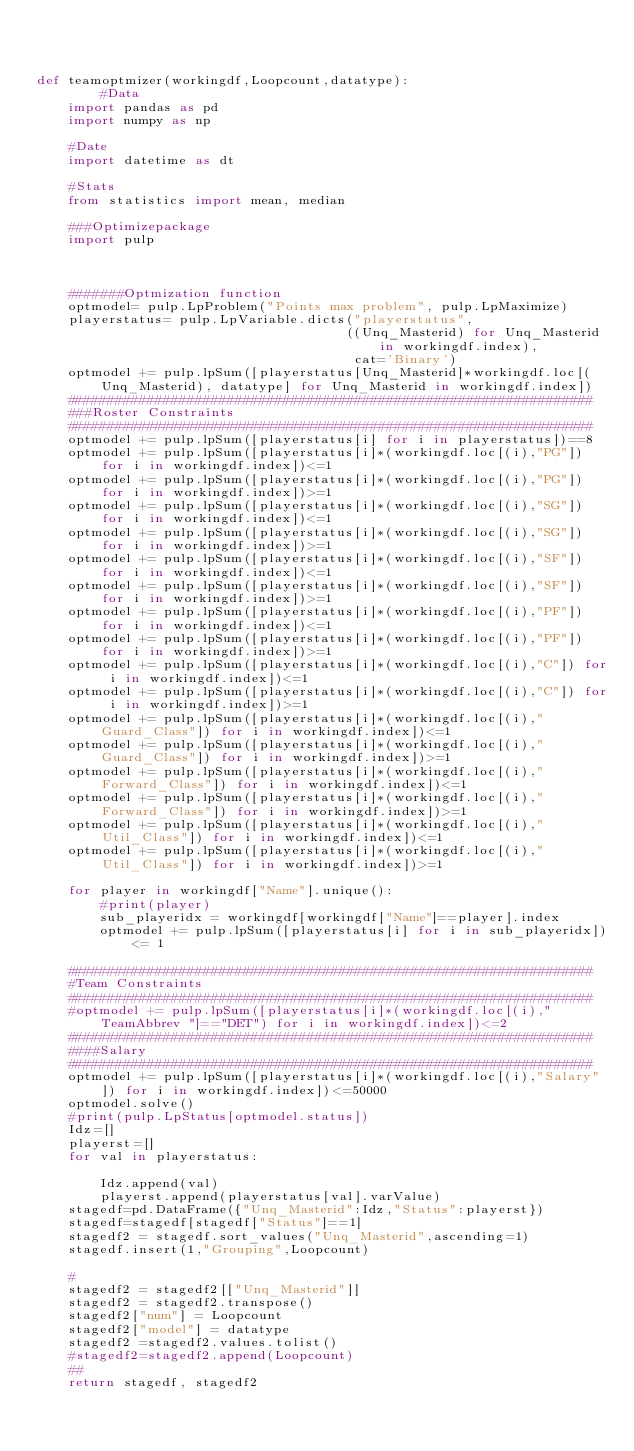<code> <loc_0><loc_0><loc_500><loc_500><_Python_>


def teamoptmizer(workingdf,Loopcount,datatype):
        #Data
    import pandas as pd
    import numpy as np

    #Date
    import datetime as dt   

    #Stats
    from statistics import mean, median

    ###Optimizepackage
    import pulp



    #######Optmization function
    optmodel= pulp.LpProblem("Points max problem", pulp.LpMaximize)
    playerstatus= pulp.LpVariable.dicts("playerstatus",
                                       ((Unq_Masterid) for Unq_Masterid in workingdf.index),
                                        cat='Binary')
    optmodel += pulp.lpSum([playerstatus[Unq_Masterid]*workingdf.loc[(Unq_Masterid), datatype] for Unq_Masterid in workingdf.index])
    ##################################################################
    ###Roster Constraints
    ##################################################################
    optmodel += pulp.lpSum([playerstatus[i] for i in playerstatus])==8
    optmodel += pulp.lpSum([playerstatus[i]*(workingdf.loc[(i),"PG"]) for i in workingdf.index])<=1
    optmodel += pulp.lpSum([playerstatus[i]*(workingdf.loc[(i),"PG"]) for i in workingdf.index])>=1
    optmodel += pulp.lpSum([playerstatus[i]*(workingdf.loc[(i),"SG"]) for i in workingdf.index])<=1
    optmodel += pulp.lpSum([playerstatus[i]*(workingdf.loc[(i),"SG"]) for i in workingdf.index])>=1
    optmodel += pulp.lpSum([playerstatus[i]*(workingdf.loc[(i),"SF"]) for i in workingdf.index])<=1
    optmodel += pulp.lpSum([playerstatus[i]*(workingdf.loc[(i),"SF"]) for i in workingdf.index])>=1
    optmodel += pulp.lpSum([playerstatus[i]*(workingdf.loc[(i),"PF"]) for i in workingdf.index])<=1
    optmodel += pulp.lpSum([playerstatus[i]*(workingdf.loc[(i),"PF"]) for i in workingdf.index])>=1
    optmodel += pulp.lpSum([playerstatus[i]*(workingdf.loc[(i),"C"]) for i in workingdf.index])<=1
    optmodel += pulp.lpSum([playerstatus[i]*(workingdf.loc[(i),"C"]) for i in workingdf.index])>=1
    optmodel += pulp.lpSum([playerstatus[i]*(workingdf.loc[(i),"Guard_Class"]) for i in workingdf.index])<=1
    optmodel += pulp.lpSum([playerstatus[i]*(workingdf.loc[(i),"Guard_Class"]) for i in workingdf.index])>=1
    optmodel += pulp.lpSum([playerstatus[i]*(workingdf.loc[(i),"Forward_Class"]) for i in workingdf.index])<=1
    optmodel += pulp.lpSum([playerstatus[i]*(workingdf.loc[(i),"Forward_Class"]) for i in workingdf.index])>=1
    optmodel += pulp.lpSum([playerstatus[i]*(workingdf.loc[(i),"Util_Class"]) for i in workingdf.index])<=1
    optmodel += pulp.lpSum([playerstatus[i]*(workingdf.loc[(i),"Util_Class"]) for i in workingdf.index])>=1

    for player in workingdf["Name"].unique():
        #print(player)
        sub_playeridx = workingdf[workingdf["Name"]==player].index
        optmodel += pulp.lpSum([playerstatus[i] for i in sub_playeridx])<= 1

    ##################################################################
    #Team Constraints
    ##################################################################
    #optmodel += pulp.lpSum([playerstatus[i]*(workingdf.loc[(i),"TeamAbbrev "]=="DET") for i in workingdf.index])<=2
    ##################################################################
    ####Salary
    ##################################################################
    optmodel += pulp.lpSum([playerstatus[i]*(workingdf.loc[(i),"Salary"]) for i in workingdf.index])<=50000
    optmodel.solve()
    #print(pulp.LpStatus[optmodel.status])
    Idz=[]
    playerst=[]
    for val in playerstatus:
        
        Idz.append(val)
        playerst.append(playerstatus[val].varValue)
    stagedf=pd.DataFrame({"Unq_Masterid":Idz,"Status":playerst})
    stagedf=stagedf[stagedf["Status"]==1]
    stagedf2 = stagedf.sort_values("Unq_Masterid",ascending=1)
    stagedf.insert(1,"Grouping",Loopcount)
    
    #
    stagedf2 = stagedf2[["Unq_Masterid"]]
    stagedf2 = stagedf2.transpose()
    stagedf2["num"] = Loopcount 
    stagedf2["model"] = datatype
    stagedf2 =stagedf2.values.tolist()
    #stagedf2=stagedf2.append(Loopcount)
    ##
    return stagedf, stagedf2</code> 